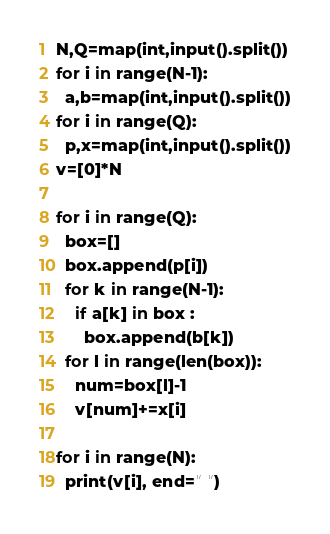Convert code to text. <code><loc_0><loc_0><loc_500><loc_500><_Python_>N,Q=map(int,input().split())
for i in range(N-1):
  a,b=map(int,input().split())
for i in range(Q):
  p,x=map(int,input().split())
v=[0]*N

for i in range(Q):
  box=[]
  box.append(p[i])
  for k in range(N-1):
    if a[k] in box :
      box.append(b[k])
  for l in range(len(box)):
    num=box[l]-1
    v[num]+=x[i]

for i in range(N):
  print(v[i], end=" ")</code> 